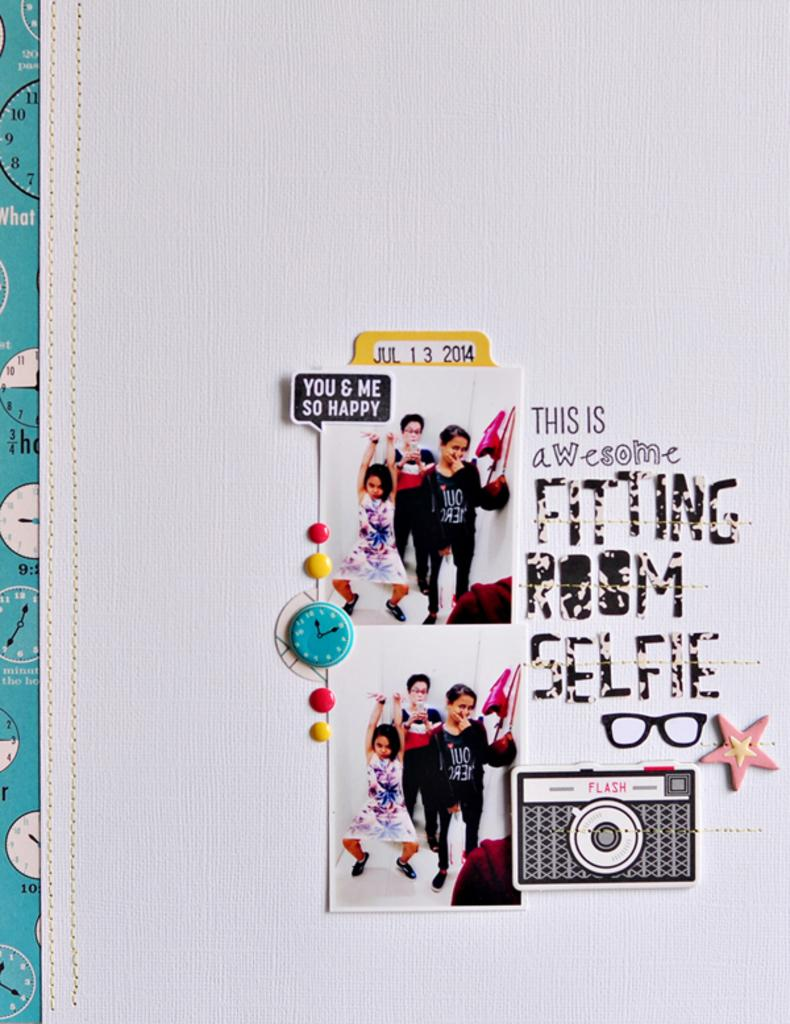<image>
Write a terse but informative summary of the picture. A photo collage on the wall says This is awesome fitting room selfie. 